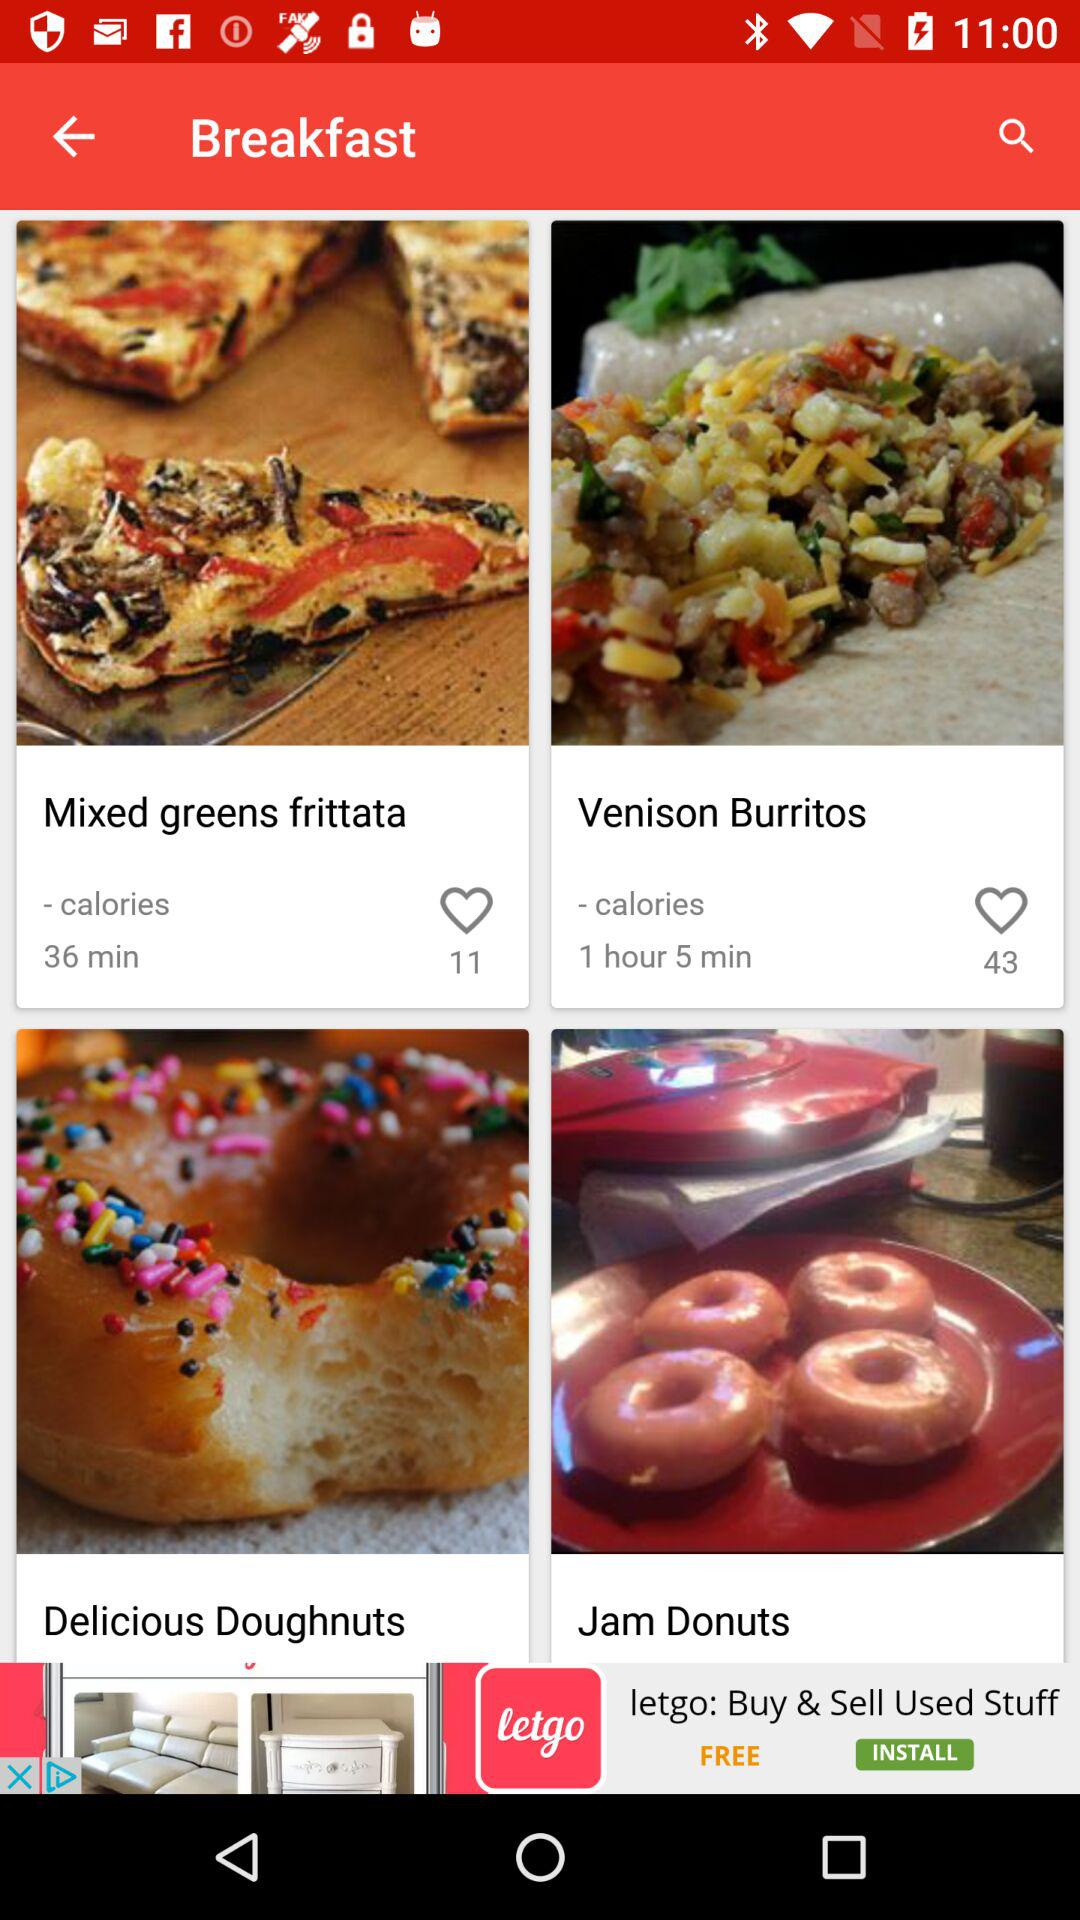How many people like mixed greens frittata? There are 11 people who like mixed greens frittata. 